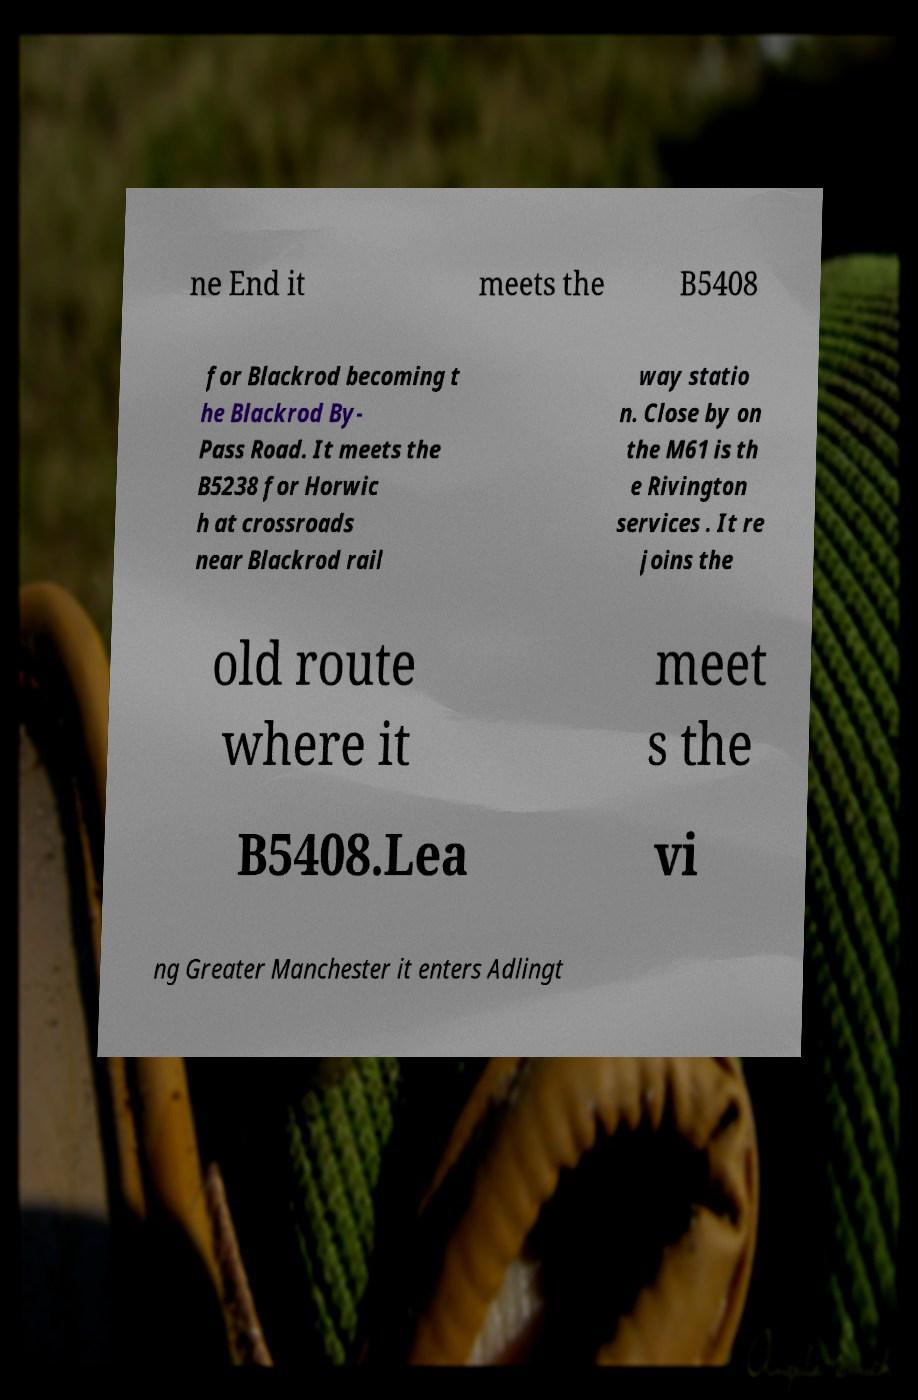Please read and relay the text visible in this image. What does it say? ne End it meets the B5408 for Blackrod becoming t he Blackrod By- Pass Road. It meets the B5238 for Horwic h at crossroads near Blackrod rail way statio n. Close by on the M61 is th e Rivington services . It re joins the old route where it meet s the B5408.Lea vi ng Greater Manchester it enters Adlingt 